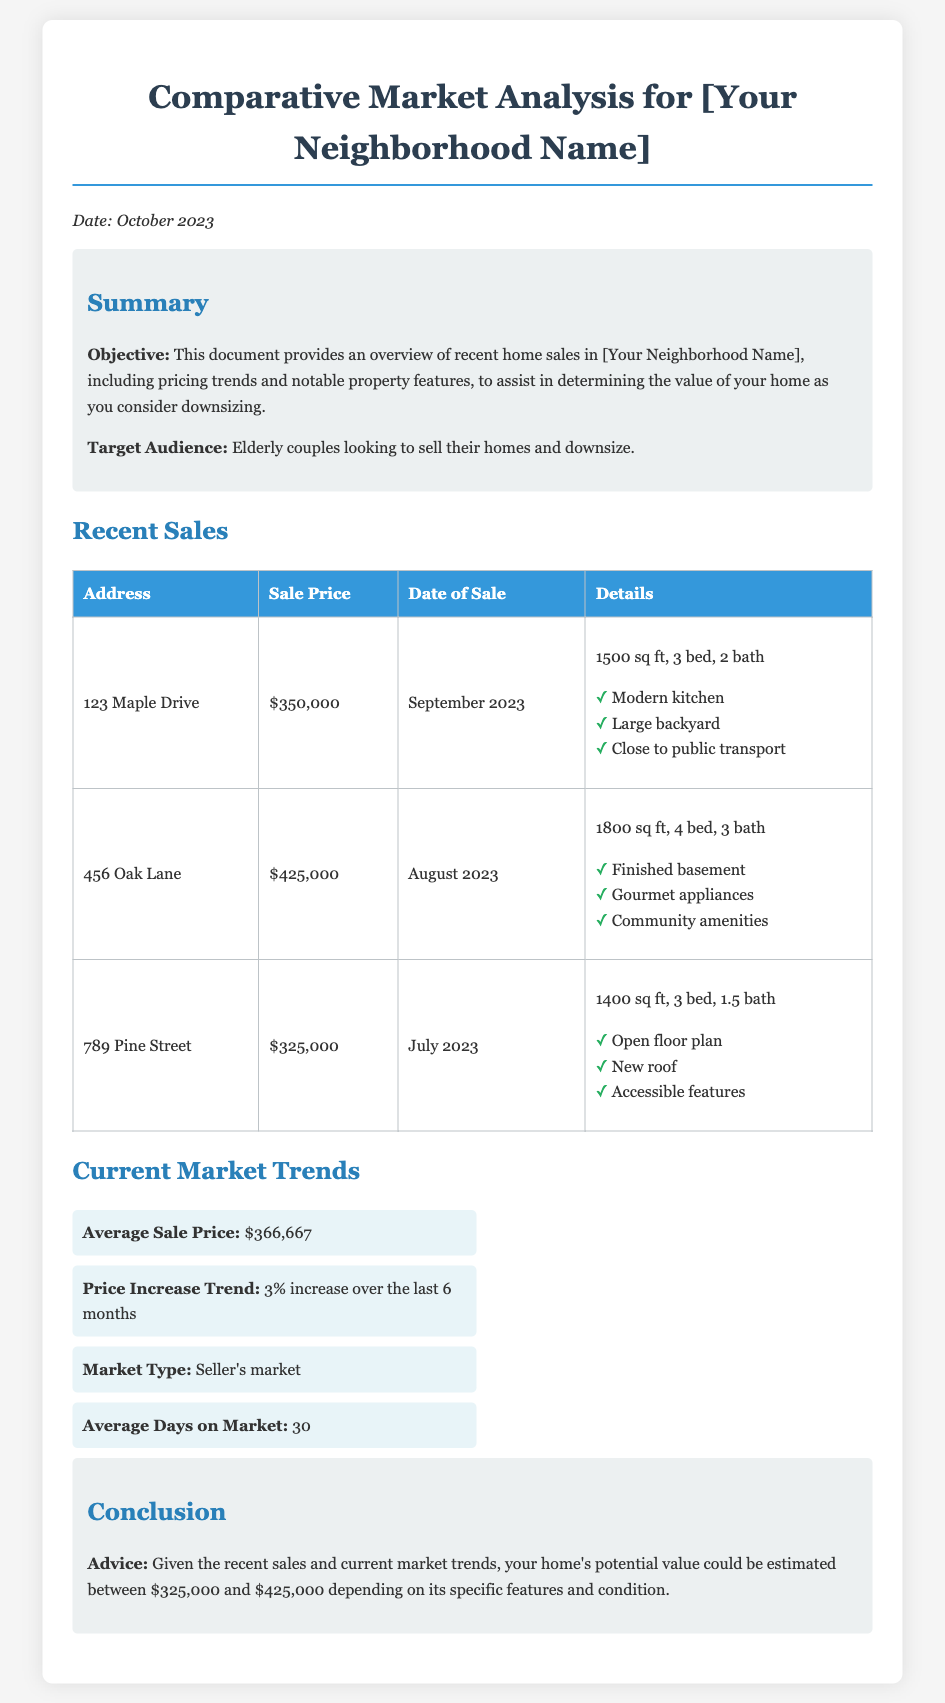What is the average sale price? The average sale price is calculated from the recent sales listed in the document. It is mentioned in the Current Market Trends section.
Answer: $366,667 What is the address of the home sold for $425,000? The address corresponding to the sale price of $425,000 is specified in the Recent Sales table.
Answer: 456 Oak Lane How many bedrooms does the property at 789 Pine Street have? The number of bedrooms for the property is listed in the property details in the Recent Sales table.
Answer: 3 bed What is the date of sale for the property on Maple Drive? The specific date of sale is presented in the Recent Sales table under the Date of Sale column.
Answer: September 2023 What is the price increase trend over the last 6 months? The price increase trend is summarized in the Current Market Trends section.
Answer: 3% increase What type of market is indicated in the document? The type of market is defined in the Current Market Trends section based on the overall sales conditions.
Answer: Seller's market What could be the estimated value range of your home? The potential value range of your home based on recent sales and trends is provided in the Conclusion section.
Answer: $325,000 to $425,000 How many days is the average home on the market? The average days on market is specified in the Current Market Trends section of the document.
Answer: 30 What key feature does the property at 123 Maple Drive have? One notable feature of the property is highlighted in the details of the Recent Sales table.
Answer: Modern kitchen 